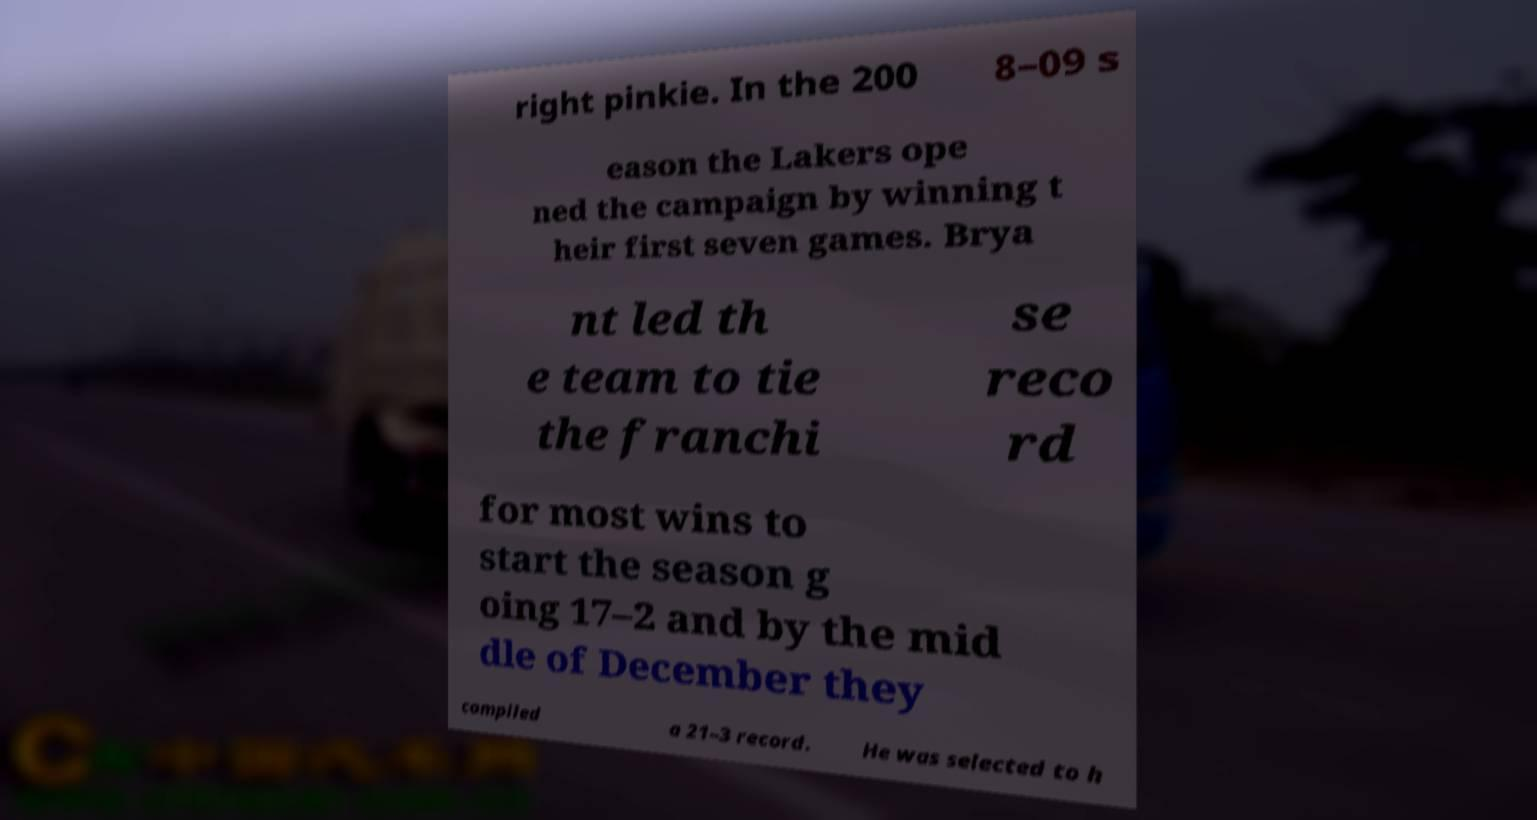What messages or text are displayed in this image? I need them in a readable, typed format. right pinkie. In the 200 8–09 s eason the Lakers ope ned the campaign by winning t heir first seven games. Brya nt led th e team to tie the franchi se reco rd for most wins to start the season g oing 17–2 and by the mid dle of December they compiled a 21–3 record. He was selected to h 